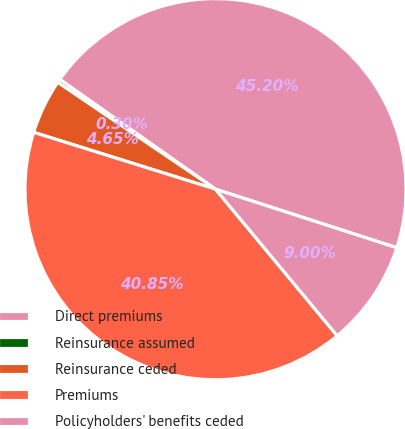Convert chart. <chart><loc_0><loc_0><loc_500><loc_500><pie_chart><fcel>Direct premiums<fcel>Reinsurance assumed<fcel>Reinsurance ceded<fcel>Premiums<fcel>Policyholders' benefits ceded<nl><fcel>45.19%<fcel>0.3%<fcel>4.65%<fcel>40.84%<fcel>9.0%<nl></chart> 